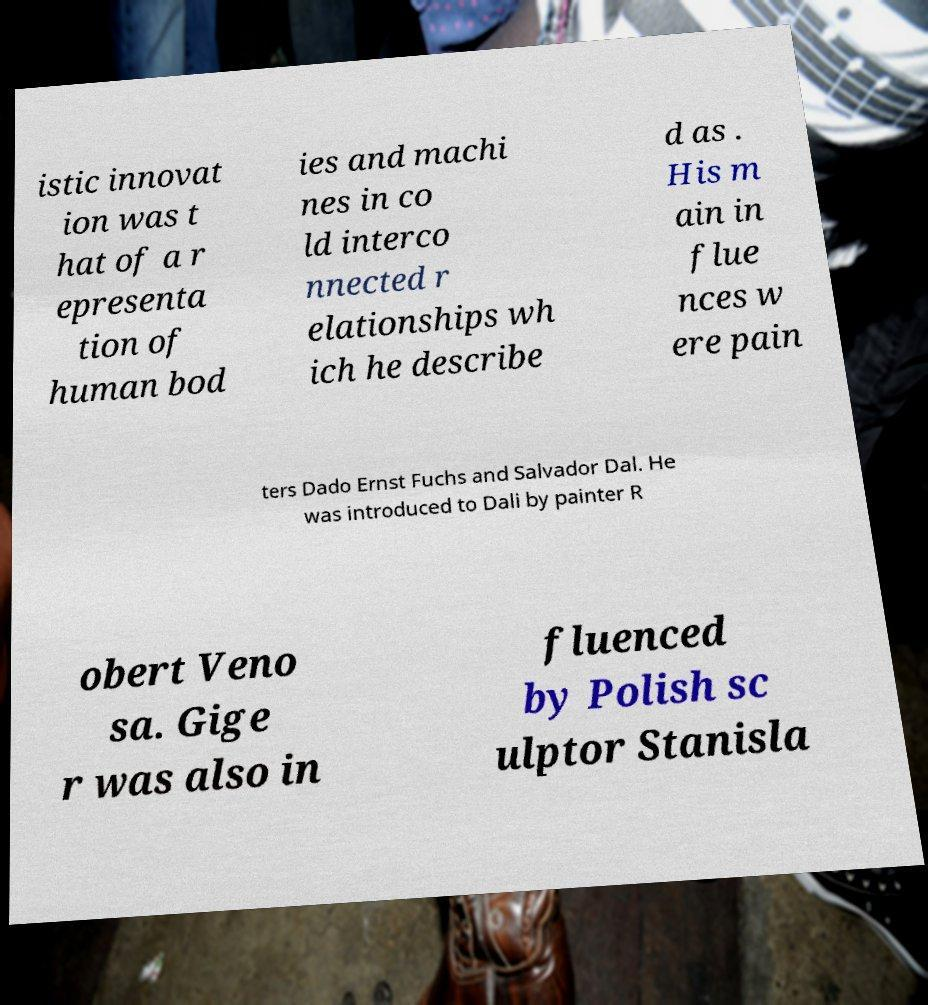Could you assist in decoding the text presented in this image and type it out clearly? istic innovat ion was t hat of a r epresenta tion of human bod ies and machi nes in co ld interco nnected r elationships wh ich he describe d as . His m ain in flue nces w ere pain ters Dado Ernst Fuchs and Salvador Dal. He was introduced to Dali by painter R obert Veno sa. Gige r was also in fluenced by Polish sc ulptor Stanisla 